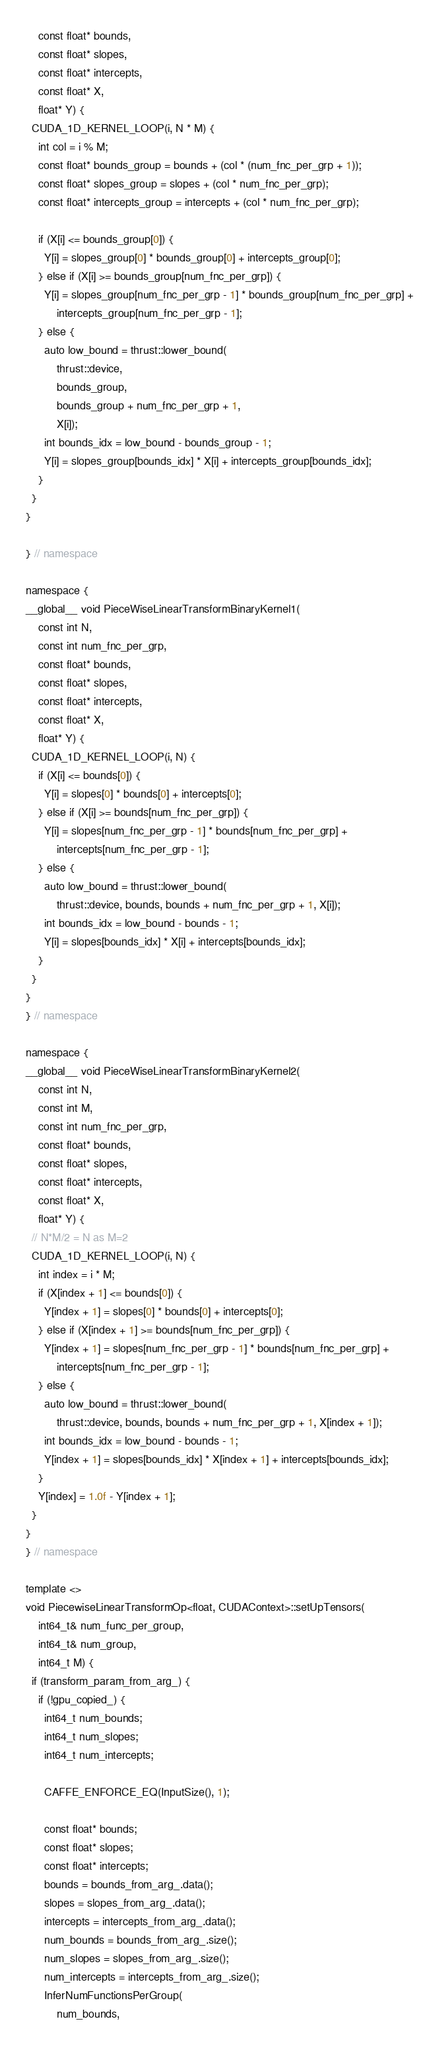Convert code to text. <code><loc_0><loc_0><loc_500><loc_500><_Cuda_>    const float* bounds,
    const float* slopes,
    const float* intercepts,
    const float* X,
    float* Y) {
  CUDA_1D_KERNEL_LOOP(i, N * M) {
    int col = i % M;
    const float* bounds_group = bounds + (col * (num_fnc_per_grp + 1));
    const float* slopes_group = slopes + (col * num_fnc_per_grp);
    const float* intercepts_group = intercepts + (col * num_fnc_per_grp);

    if (X[i] <= bounds_group[0]) {
      Y[i] = slopes_group[0] * bounds_group[0] + intercepts_group[0];
    } else if (X[i] >= bounds_group[num_fnc_per_grp]) {
      Y[i] = slopes_group[num_fnc_per_grp - 1] * bounds_group[num_fnc_per_grp] +
          intercepts_group[num_fnc_per_grp - 1];
    } else {
      auto low_bound = thrust::lower_bound(
          thrust::device,
          bounds_group,
          bounds_group + num_fnc_per_grp + 1,
          X[i]);
      int bounds_idx = low_bound - bounds_group - 1;
      Y[i] = slopes_group[bounds_idx] * X[i] + intercepts_group[bounds_idx];
    }
  }
}

} // namespace

namespace {
__global__ void PieceWiseLinearTransformBinaryKernel1(
    const int N,
    const int num_fnc_per_grp,
    const float* bounds,
    const float* slopes,
    const float* intercepts,
    const float* X,
    float* Y) {
  CUDA_1D_KERNEL_LOOP(i, N) {
    if (X[i] <= bounds[0]) {
      Y[i] = slopes[0] * bounds[0] + intercepts[0];
    } else if (X[i] >= bounds[num_fnc_per_grp]) {
      Y[i] = slopes[num_fnc_per_grp - 1] * bounds[num_fnc_per_grp] +
          intercepts[num_fnc_per_grp - 1];
    } else {
      auto low_bound = thrust::lower_bound(
          thrust::device, bounds, bounds + num_fnc_per_grp + 1, X[i]);
      int bounds_idx = low_bound - bounds - 1;
      Y[i] = slopes[bounds_idx] * X[i] + intercepts[bounds_idx];
    }
  }
}
} // namespace

namespace {
__global__ void PieceWiseLinearTransformBinaryKernel2(
    const int N,
    const int M,
    const int num_fnc_per_grp,
    const float* bounds,
    const float* slopes,
    const float* intercepts,
    const float* X,
    float* Y) {
  // N*M/2 = N as M=2
  CUDA_1D_KERNEL_LOOP(i, N) {
    int index = i * M;
    if (X[index + 1] <= bounds[0]) {
      Y[index + 1] = slopes[0] * bounds[0] + intercepts[0];
    } else if (X[index + 1] >= bounds[num_fnc_per_grp]) {
      Y[index + 1] = slopes[num_fnc_per_grp - 1] * bounds[num_fnc_per_grp] +
          intercepts[num_fnc_per_grp - 1];
    } else {
      auto low_bound = thrust::lower_bound(
          thrust::device, bounds, bounds + num_fnc_per_grp + 1, X[index + 1]);
      int bounds_idx = low_bound - bounds - 1;
      Y[index + 1] = slopes[bounds_idx] * X[index + 1] + intercepts[bounds_idx];
    }
    Y[index] = 1.0f - Y[index + 1];
  }
}
} // namespace

template <>
void PiecewiseLinearTransformOp<float, CUDAContext>::setUpTensors(
    int64_t& num_func_per_group,
    int64_t& num_group,
    int64_t M) {
  if (transform_param_from_arg_) {
    if (!gpu_copied_) {
      int64_t num_bounds;
      int64_t num_slopes;
      int64_t num_intercepts;

      CAFFE_ENFORCE_EQ(InputSize(), 1);

      const float* bounds;
      const float* slopes;
      const float* intercepts;
      bounds = bounds_from_arg_.data();
      slopes = slopes_from_arg_.data();
      intercepts = intercepts_from_arg_.data();
      num_bounds = bounds_from_arg_.size();
      num_slopes = slopes_from_arg_.size();
      num_intercepts = intercepts_from_arg_.size();
      InferNumFunctionsPerGroup(
          num_bounds,</code> 